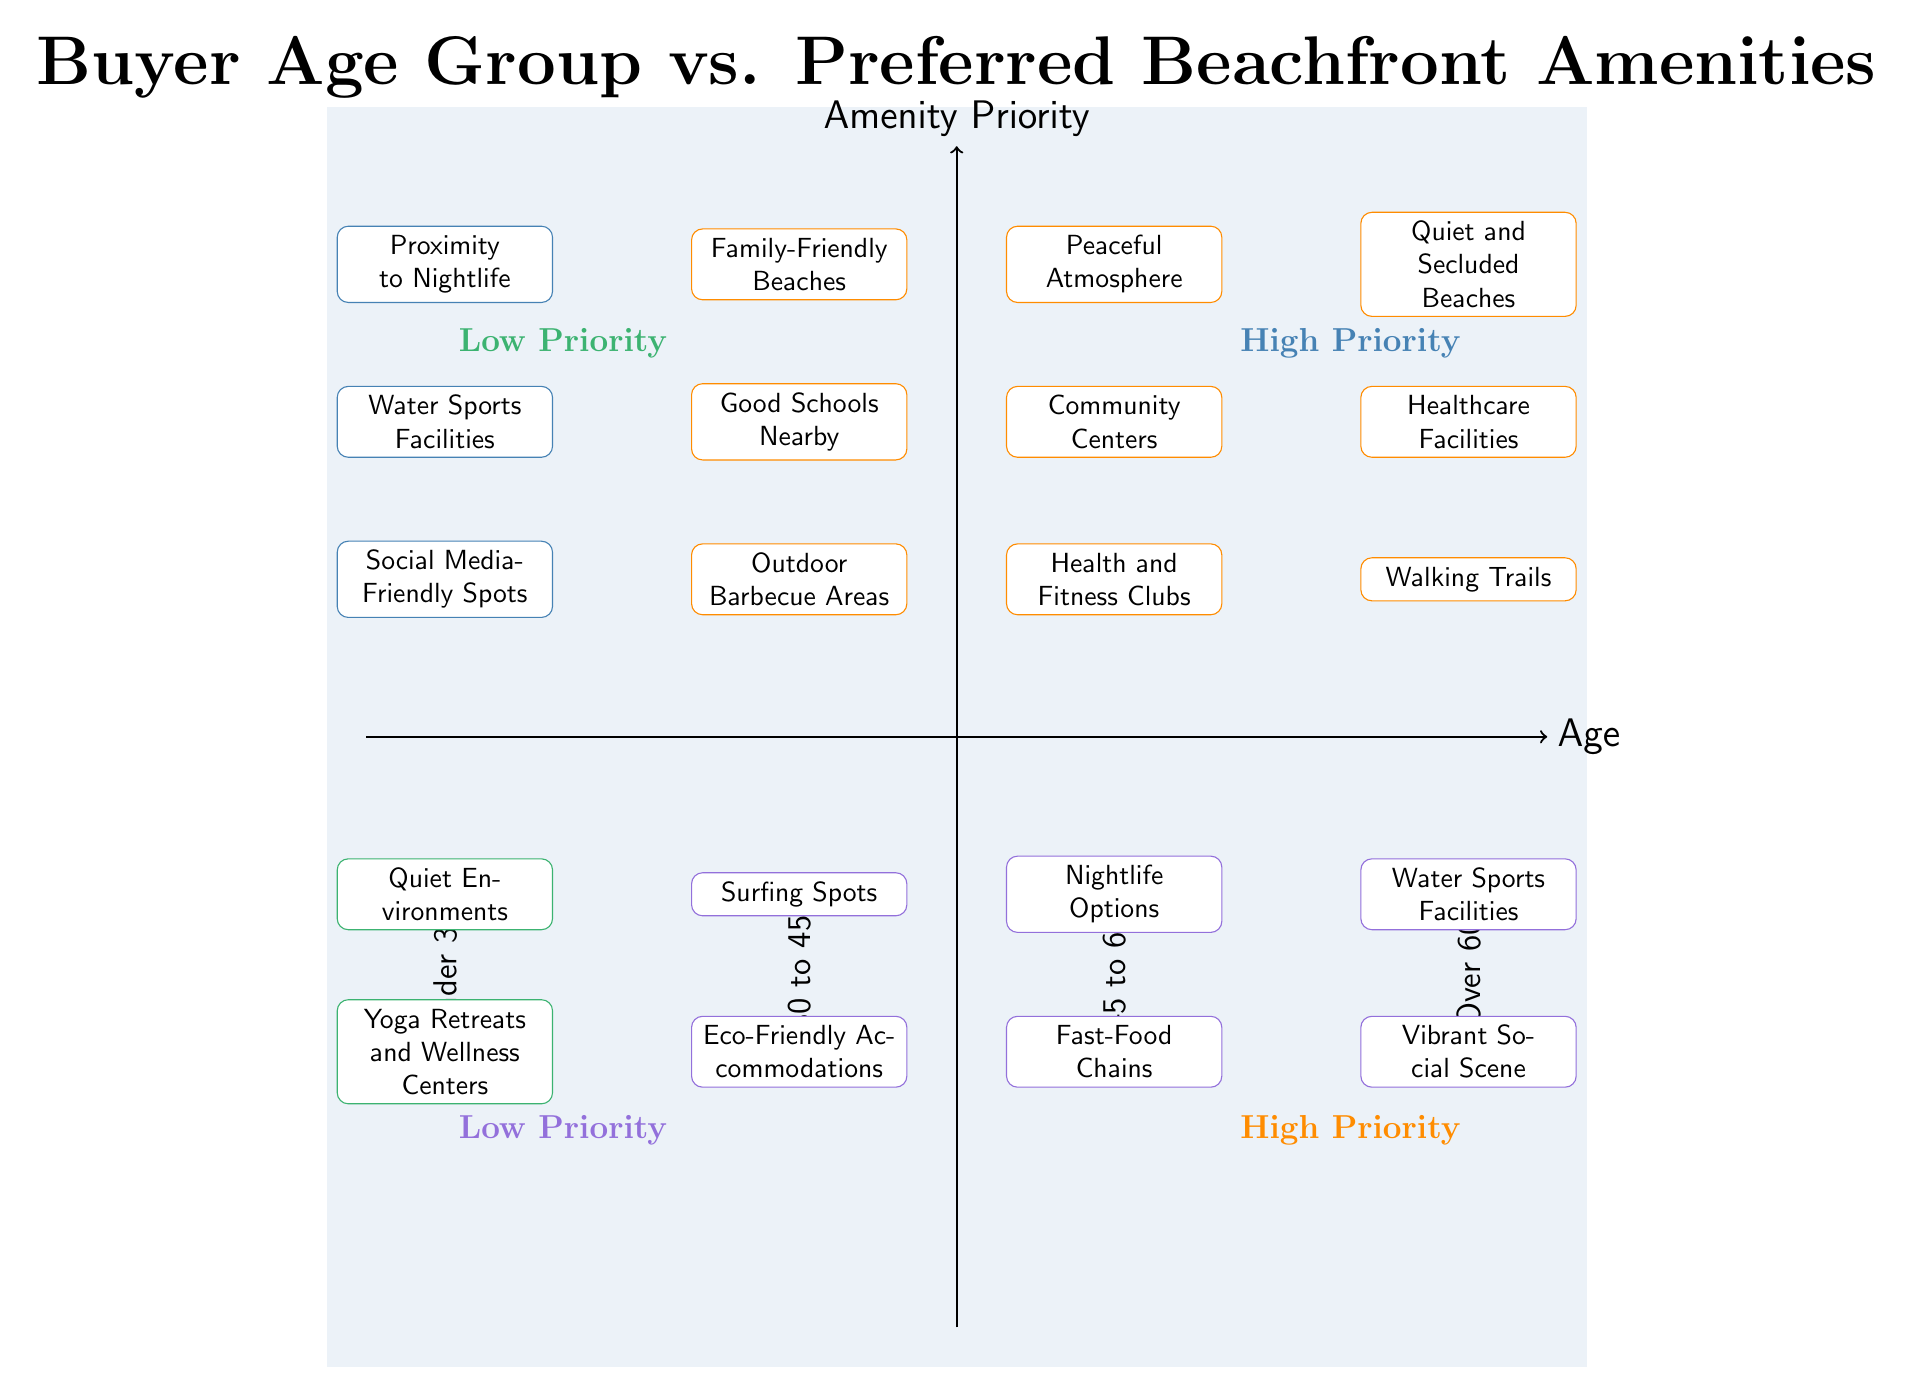What are the high-priority amenities for the Under 30 age group? The diagram indicates that the high-priority amenities for the Under 30 age group include "Proximity to Nightlife," "Water Sports Facilities," and "Social Media-Friendly Spots."
Answer: Proximity to Nightlife, Water Sports Facilities, Social Media-Friendly Spots Which age group prefers "Healthcare Facilities" as a high priority? By examining the diagram, it can be seen that the age group that prefers "Healthcare Facilities" as a high priority is "Over 60."
Answer: Over 60 How many low-priority amenities are listed for the 30 to 45 age group? The diagram shows that there are two low-priority amenities listed for the 30 to 45 age group: "Surfing Spots" and "Eco-Friendly Accommodations."
Answer: 2 Is "Nightlife Options" a high-priority amenity for any age group? The diagram specifically categorizes "Nightlife Options" under low-priority for the 45 to 60 age group, which indicates that it is not a high priority for any age group.
Answer: No Which two age groups share the preference for "Water Sports Facilities" and where is it categorized? Both the Under 30 and Over 60 age groups have "Water Sports Facilities" listed, but for Under 30, it is categorized as high priority, and for Over 60, it is low priority.
Answer: Under 30 (high priority), Over 60 (low priority) What is the overall pattern seen in priorities as age increases from Under 30 to Over 60? As the age groups increase from Under 30 to Over 60, the priority shifts from amenities focused on social and active enjoyment (like nightlife and water sports) to those prioritizing peace and quiet (like healthcare facilities and secluded beaches).
Answer: Shift towards peaceful amenities Identify one low-priority amenity for the age group 45 to 60. The diagram shows that "Fast-Food Chains" is one of the low-priority amenities identified for the age group 45 to 60.
Answer: Fast-Food Chains How many high-priority amenities are listed for the Over 60 age group? The diagram indicates that there are three high-priority amenities for the Over 60 age group: "Quiet and Secluded Beaches," "Healthcare Facilities," and "Walking Trails."
Answer: 3 